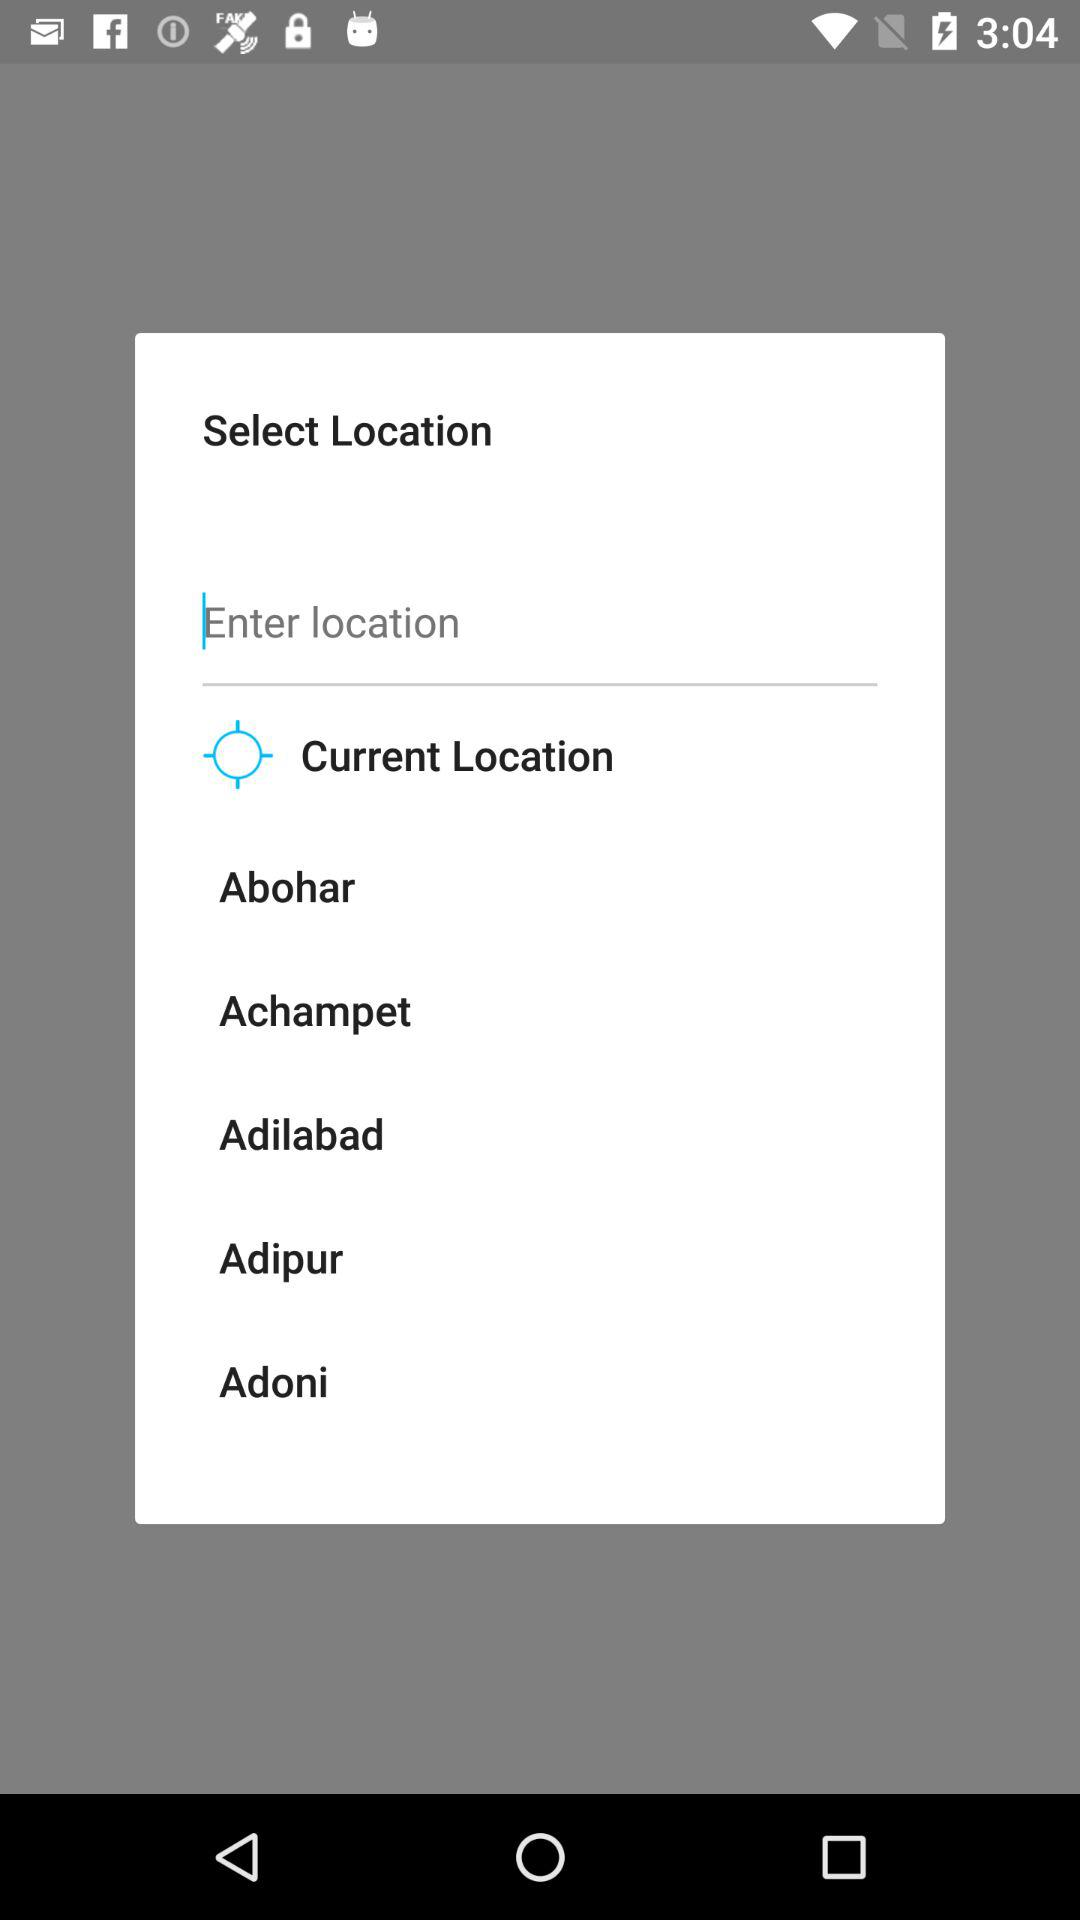What is the current location?
When the provided information is insufficient, respond with <no answer>. <no answer> 